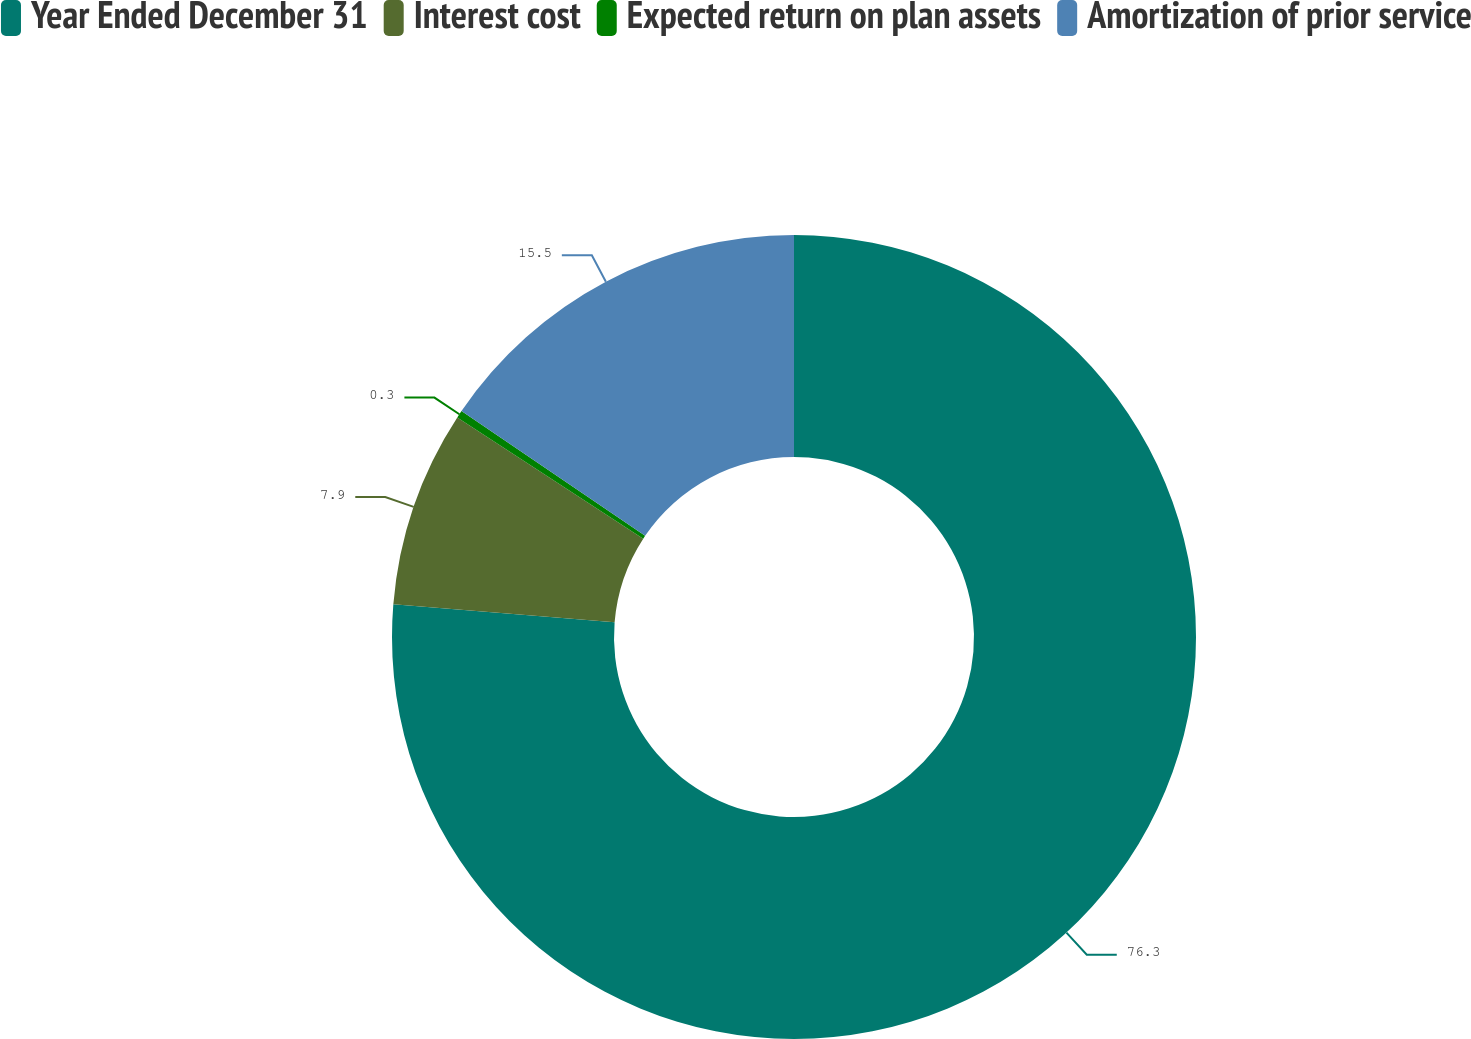Convert chart to OTSL. <chart><loc_0><loc_0><loc_500><loc_500><pie_chart><fcel>Year Ended December 31<fcel>Interest cost<fcel>Expected return on plan assets<fcel>Amortization of prior service<nl><fcel>76.29%<fcel>7.9%<fcel>0.3%<fcel>15.5%<nl></chart> 